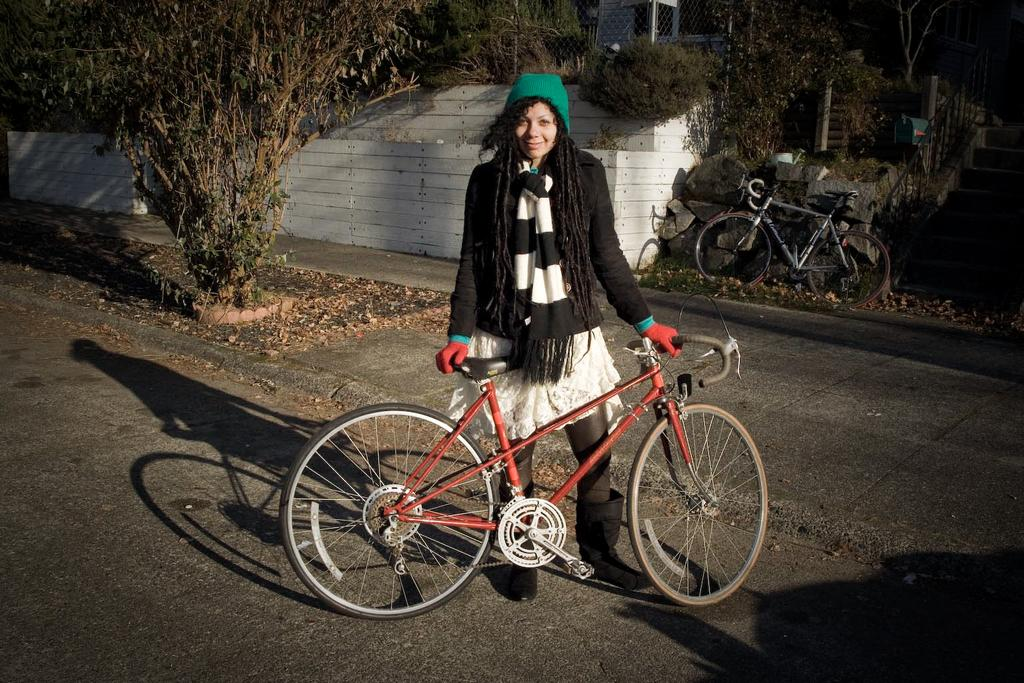Who is present in the image? There is a woman in the image. What is the woman wearing? The woman is wearing a black jacket. What is the woman holding in the image? The woman is holding a cycle. What can be seen at the bottom of the image? There is a road at the bottom of the image. What type of vegetation is visible in the background? There are plants in the background of the image. What architectural feature is present in the background? There is a wall in the background of the image. Where is the faucet located in the image? There is no faucet present in the image. What does the woman believe about the cycle she is holding? The image does not provide any information about the woman's beliefs or thoughts regarding the cycle. 